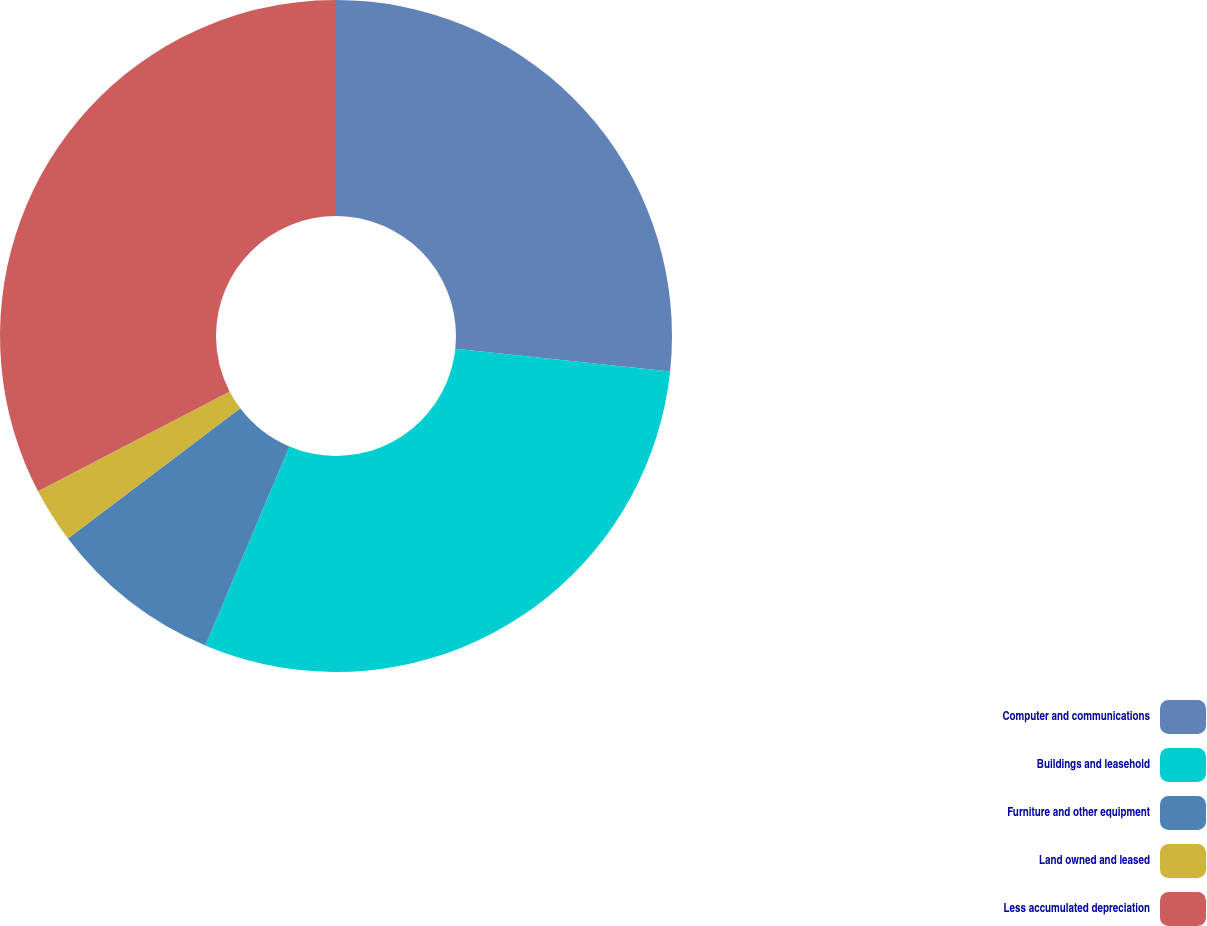<chart> <loc_0><loc_0><loc_500><loc_500><pie_chart><fcel>Computer and communications<fcel>Buildings and leasehold<fcel>Furniture and other equipment<fcel>Land owned and leased<fcel>Less accumulated depreciation<nl><fcel>26.69%<fcel>29.67%<fcel>8.34%<fcel>2.65%<fcel>32.65%<nl></chart> 